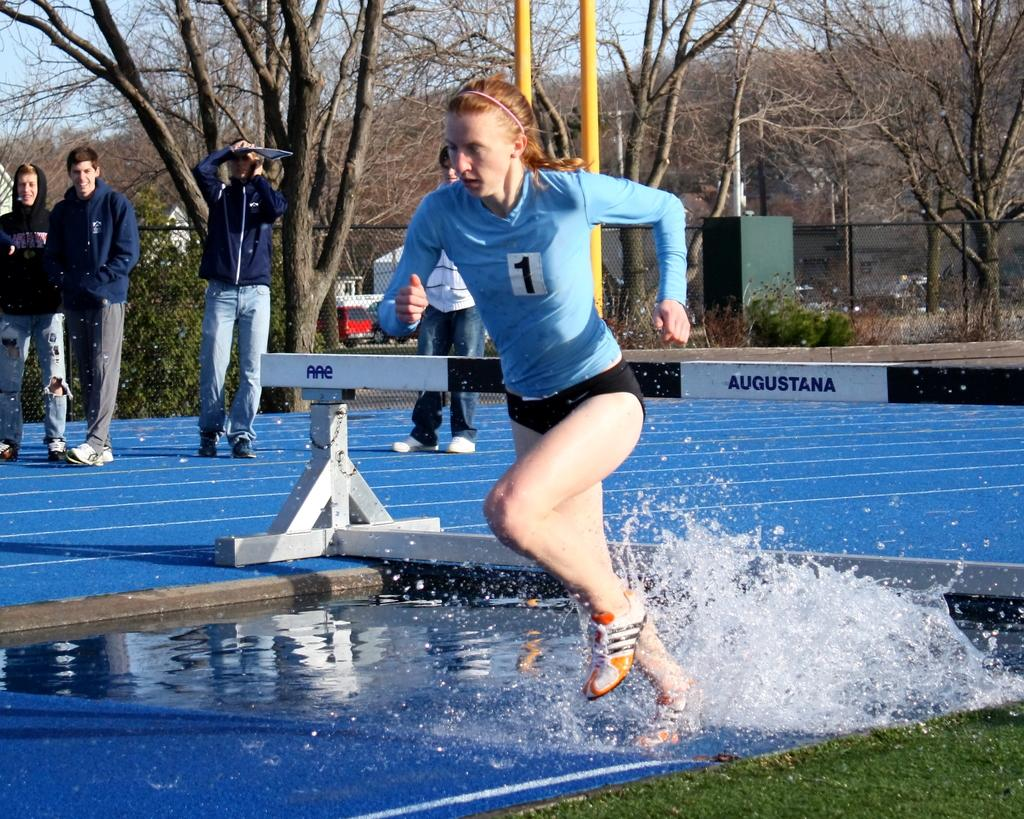What is the woman in the image doing? The woman is running on the water surface. What can be seen in the background of the image? There is an iron rod and four people standing in the background, as well as trees. What type of silver wound can be seen on the woman's chin in the image? There is no silver wound or any wound on the woman's chin in the image. 